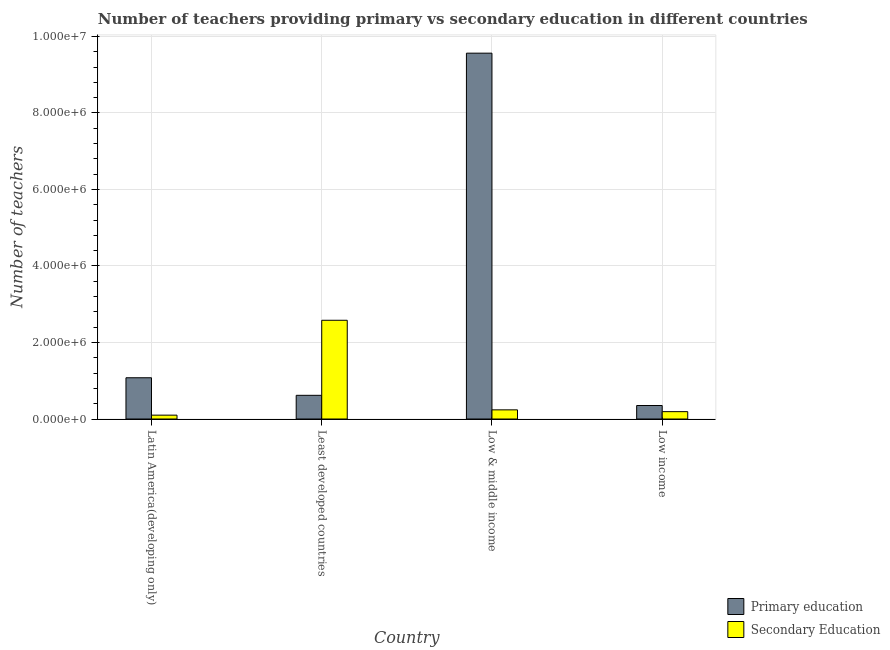How many different coloured bars are there?
Make the answer very short. 2. How many groups of bars are there?
Ensure brevity in your answer.  4. Are the number of bars per tick equal to the number of legend labels?
Your answer should be compact. Yes. How many bars are there on the 3rd tick from the left?
Make the answer very short. 2. How many bars are there on the 1st tick from the right?
Offer a very short reply. 2. What is the label of the 4th group of bars from the left?
Make the answer very short. Low income. In how many cases, is the number of bars for a given country not equal to the number of legend labels?
Offer a very short reply. 0. What is the number of secondary teachers in Least developed countries?
Offer a very short reply. 2.58e+06. Across all countries, what is the maximum number of secondary teachers?
Provide a succinct answer. 2.58e+06. Across all countries, what is the minimum number of secondary teachers?
Offer a very short reply. 1.01e+05. In which country was the number of secondary teachers maximum?
Offer a very short reply. Least developed countries. In which country was the number of secondary teachers minimum?
Offer a terse response. Latin America(developing only). What is the total number of secondary teachers in the graph?
Offer a terse response. 3.11e+06. What is the difference between the number of primary teachers in Least developed countries and that in Low & middle income?
Make the answer very short. -8.94e+06. What is the difference between the number of primary teachers in Latin America(developing only) and the number of secondary teachers in Least developed countries?
Your answer should be compact. -1.50e+06. What is the average number of secondary teachers per country?
Offer a very short reply. 7.79e+05. What is the difference between the number of secondary teachers and number of primary teachers in Low income?
Make the answer very short. -1.61e+05. What is the ratio of the number of primary teachers in Latin America(developing only) to that in Low & middle income?
Provide a succinct answer. 0.11. What is the difference between the highest and the second highest number of secondary teachers?
Keep it short and to the point. 2.34e+06. What is the difference between the highest and the lowest number of secondary teachers?
Provide a succinct answer. 2.48e+06. What does the 2nd bar from the left in Low & middle income represents?
Make the answer very short. Secondary Education. What does the 2nd bar from the right in Least developed countries represents?
Your answer should be compact. Primary education. Are all the bars in the graph horizontal?
Provide a short and direct response. No. Are the values on the major ticks of Y-axis written in scientific E-notation?
Your answer should be very brief. Yes. Does the graph contain grids?
Ensure brevity in your answer.  Yes. How are the legend labels stacked?
Give a very brief answer. Vertical. What is the title of the graph?
Provide a succinct answer. Number of teachers providing primary vs secondary education in different countries. Does "Male labourers" appear as one of the legend labels in the graph?
Offer a very short reply. No. What is the label or title of the Y-axis?
Provide a short and direct response. Number of teachers. What is the Number of teachers in Primary education in Latin America(developing only)?
Your response must be concise. 1.08e+06. What is the Number of teachers of Secondary Education in Latin America(developing only)?
Offer a terse response. 1.01e+05. What is the Number of teachers in Primary education in Least developed countries?
Offer a terse response. 6.19e+05. What is the Number of teachers in Secondary Education in Least developed countries?
Your response must be concise. 2.58e+06. What is the Number of teachers of Primary education in Low & middle income?
Provide a short and direct response. 9.56e+06. What is the Number of teachers in Secondary Education in Low & middle income?
Offer a terse response. 2.40e+05. What is the Number of teachers of Primary education in Low income?
Your answer should be very brief. 3.53e+05. What is the Number of teachers of Secondary Education in Low income?
Give a very brief answer. 1.92e+05. Across all countries, what is the maximum Number of teachers of Primary education?
Provide a short and direct response. 9.56e+06. Across all countries, what is the maximum Number of teachers in Secondary Education?
Your answer should be very brief. 2.58e+06. Across all countries, what is the minimum Number of teachers of Primary education?
Make the answer very short. 3.53e+05. Across all countries, what is the minimum Number of teachers in Secondary Education?
Your answer should be very brief. 1.01e+05. What is the total Number of teachers in Primary education in the graph?
Provide a succinct answer. 1.16e+07. What is the total Number of teachers of Secondary Education in the graph?
Provide a succinct answer. 3.11e+06. What is the difference between the Number of teachers of Primary education in Latin America(developing only) and that in Least developed countries?
Ensure brevity in your answer.  4.59e+05. What is the difference between the Number of teachers in Secondary Education in Latin America(developing only) and that in Least developed countries?
Make the answer very short. -2.48e+06. What is the difference between the Number of teachers of Primary education in Latin America(developing only) and that in Low & middle income?
Make the answer very short. -8.49e+06. What is the difference between the Number of teachers of Secondary Education in Latin America(developing only) and that in Low & middle income?
Provide a short and direct response. -1.39e+05. What is the difference between the Number of teachers of Primary education in Latin America(developing only) and that in Low income?
Your response must be concise. 7.26e+05. What is the difference between the Number of teachers of Secondary Education in Latin America(developing only) and that in Low income?
Your answer should be very brief. -9.13e+04. What is the difference between the Number of teachers of Primary education in Least developed countries and that in Low & middle income?
Make the answer very short. -8.94e+06. What is the difference between the Number of teachers of Secondary Education in Least developed countries and that in Low & middle income?
Keep it short and to the point. 2.34e+06. What is the difference between the Number of teachers of Primary education in Least developed countries and that in Low income?
Provide a short and direct response. 2.66e+05. What is the difference between the Number of teachers of Secondary Education in Least developed countries and that in Low income?
Give a very brief answer. 2.39e+06. What is the difference between the Number of teachers in Primary education in Low & middle income and that in Low income?
Offer a very short reply. 9.21e+06. What is the difference between the Number of teachers in Secondary Education in Low & middle income and that in Low income?
Provide a short and direct response. 4.73e+04. What is the difference between the Number of teachers of Primary education in Latin America(developing only) and the Number of teachers of Secondary Education in Least developed countries?
Ensure brevity in your answer.  -1.50e+06. What is the difference between the Number of teachers in Primary education in Latin America(developing only) and the Number of teachers in Secondary Education in Low & middle income?
Your answer should be very brief. 8.39e+05. What is the difference between the Number of teachers in Primary education in Latin America(developing only) and the Number of teachers in Secondary Education in Low income?
Your answer should be very brief. 8.86e+05. What is the difference between the Number of teachers of Primary education in Least developed countries and the Number of teachers of Secondary Education in Low & middle income?
Offer a very short reply. 3.80e+05. What is the difference between the Number of teachers of Primary education in Least developed countries and the Number of teachers of Secondary Education in Low income?
Ensure brevity in your answer.  4.27e+05. What is the difference between the Number of teachers in Primary education in Low & middle income and the Number of teachers in Secondary Education in Low income?
Offer a very short reply. 9.37e+06. What is the average Number of teachers of Primary education per country?
Offer a very short reply. 2.90e+06. What is the average Number of teachers of Secondary Education per country?
Provide a succinct answer. 7.79e+05. What is the difference between the Number of teachers in Primary education and Number of teachers in Secondary Education in Latin America(developing only)?
Keep it short and to the point. 9.77e+05. What is the difference between the Number of teachers in Primary education and Number of teachers in Secondary Education in Least developed countries?
Provide a succinct answer. -1.96e+06. What is the difference between the Number of teachers of Primary education and Number of teachers of Secondary Education in Low & middle income?
Give a very brief answer. 9.32e+06. What is the difference between the Number of teachers in Primary education and Number of teachers in Secondary Education in Low income?
Provide a succinct answer. 1.61e+05. What is the ratio of the Number of teachers of Primary education in Latin America(developing only) to that in Least developed countries?
Provide a succinct answer. 1.74. What is the ratio of the Number of teachers in Secondary Education in Latin America(developing only) to that in Least developed countries?
Offer a terse response. 0.04. What is the ratio of the Number of teachers in Primary education in Latin America(developing only) to that in Low & middle income?
Give a very brief answer. 0.11. What is the ratio of the Number of teachers of Secondary Education in Latin America(developing only) to that in Low & middle income?
Ensure brevity in your answer.  0.42. What is the ratio of the Number of teachers of Primary education in Latin America(developing only) to that in Low income?
Keep it short and to the point. 3.06. What is the ratio of the Number of teachers in Secondary Education in Latin America(developing only) to that in Low income?
Make the answer very short. 0.53. What is the ratio of the Number of teachers in Primary education in Least developed countries to that in Low & middle income?
Your response must be concise. 0.06. What is the ratio of the Number of teachers of Secondary Education in Least developed countries to that in Low & middle income?
Provide a succinct answer. 10.77. What is the ratio of the Number of teachers in Primary education in Least developed countries to that in Low income?
Your answer should be compact. 1.75. What is the ratio of the Number of teachers in Secondary Education in Least developed countries to that in Low income?
Your answer should be very brief. 13.42. What is the ratio of the Number of teachers of Primary education in Low & middle income to that in Low income?
Offer a very short reply. 27.09. What is the ratio of the Number of teachers of Secondary Education in Low & middle income to that in Low income?
Give a very brief answer. 1.25. What is the difference between the highest and the second highest Number of teachers in Primary education?
Make the answer very short. 8.49e+06. What is the difference between the highest and the second highest Number of teachers in Secondary Education?
Make the answer very short. 2.34e+06. What is the difference between the highest and the lowest Number of teachers in Primary education?
Offer a very short reply. 9.21e+06. What is the difference between the highest and the lowest Number of teachers of Secondary Education?
Your answer should be very brief. 2.48e+06. 